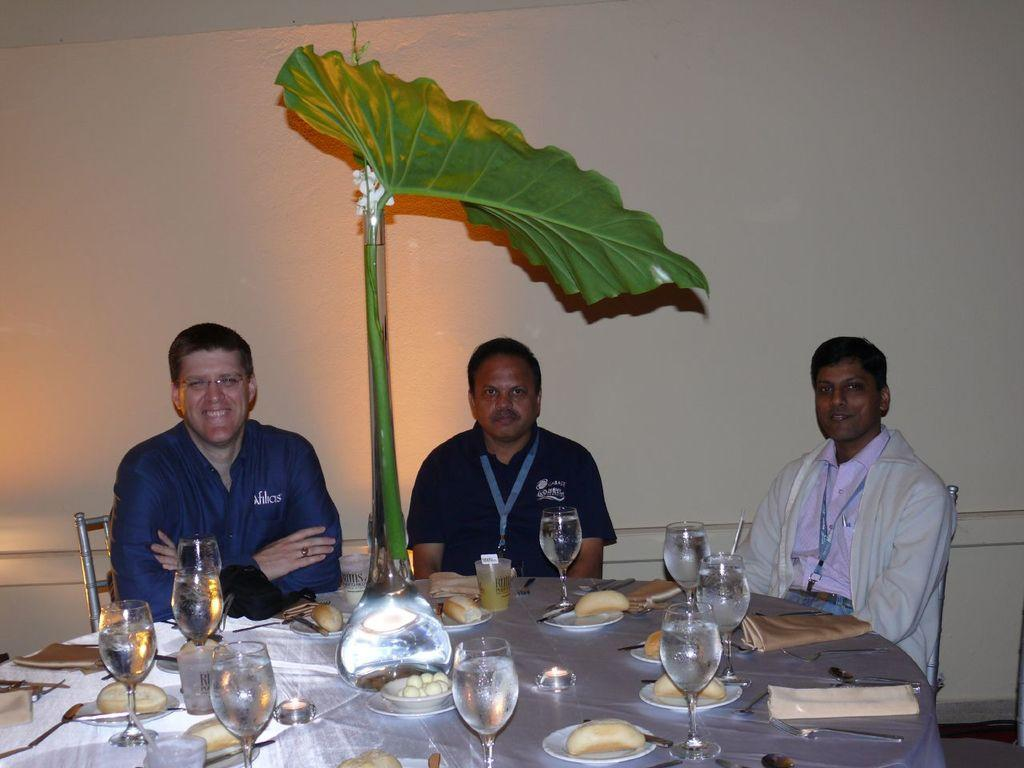How many people are in the image? There are three men in the image. What are the men doing in the image? The men are seated on chairs. What objects can be seen on the table in the image? There are glasses and plates on the table. Is there any greenery present in the image? Yes, there is a plant in the image. What type of balls are being juggled by the men in the image? There are no balls present in the image; the men are seated on chairs. What advice might the mother give to the men in the image? There is no mention of a mother in the image, so it is not possible to determine what advice she might give. 